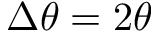Convert formula to latex. <formula><loc_0><loc_0><loc_500><loc_500>\Delta \theta = 2 \theta</formula> 